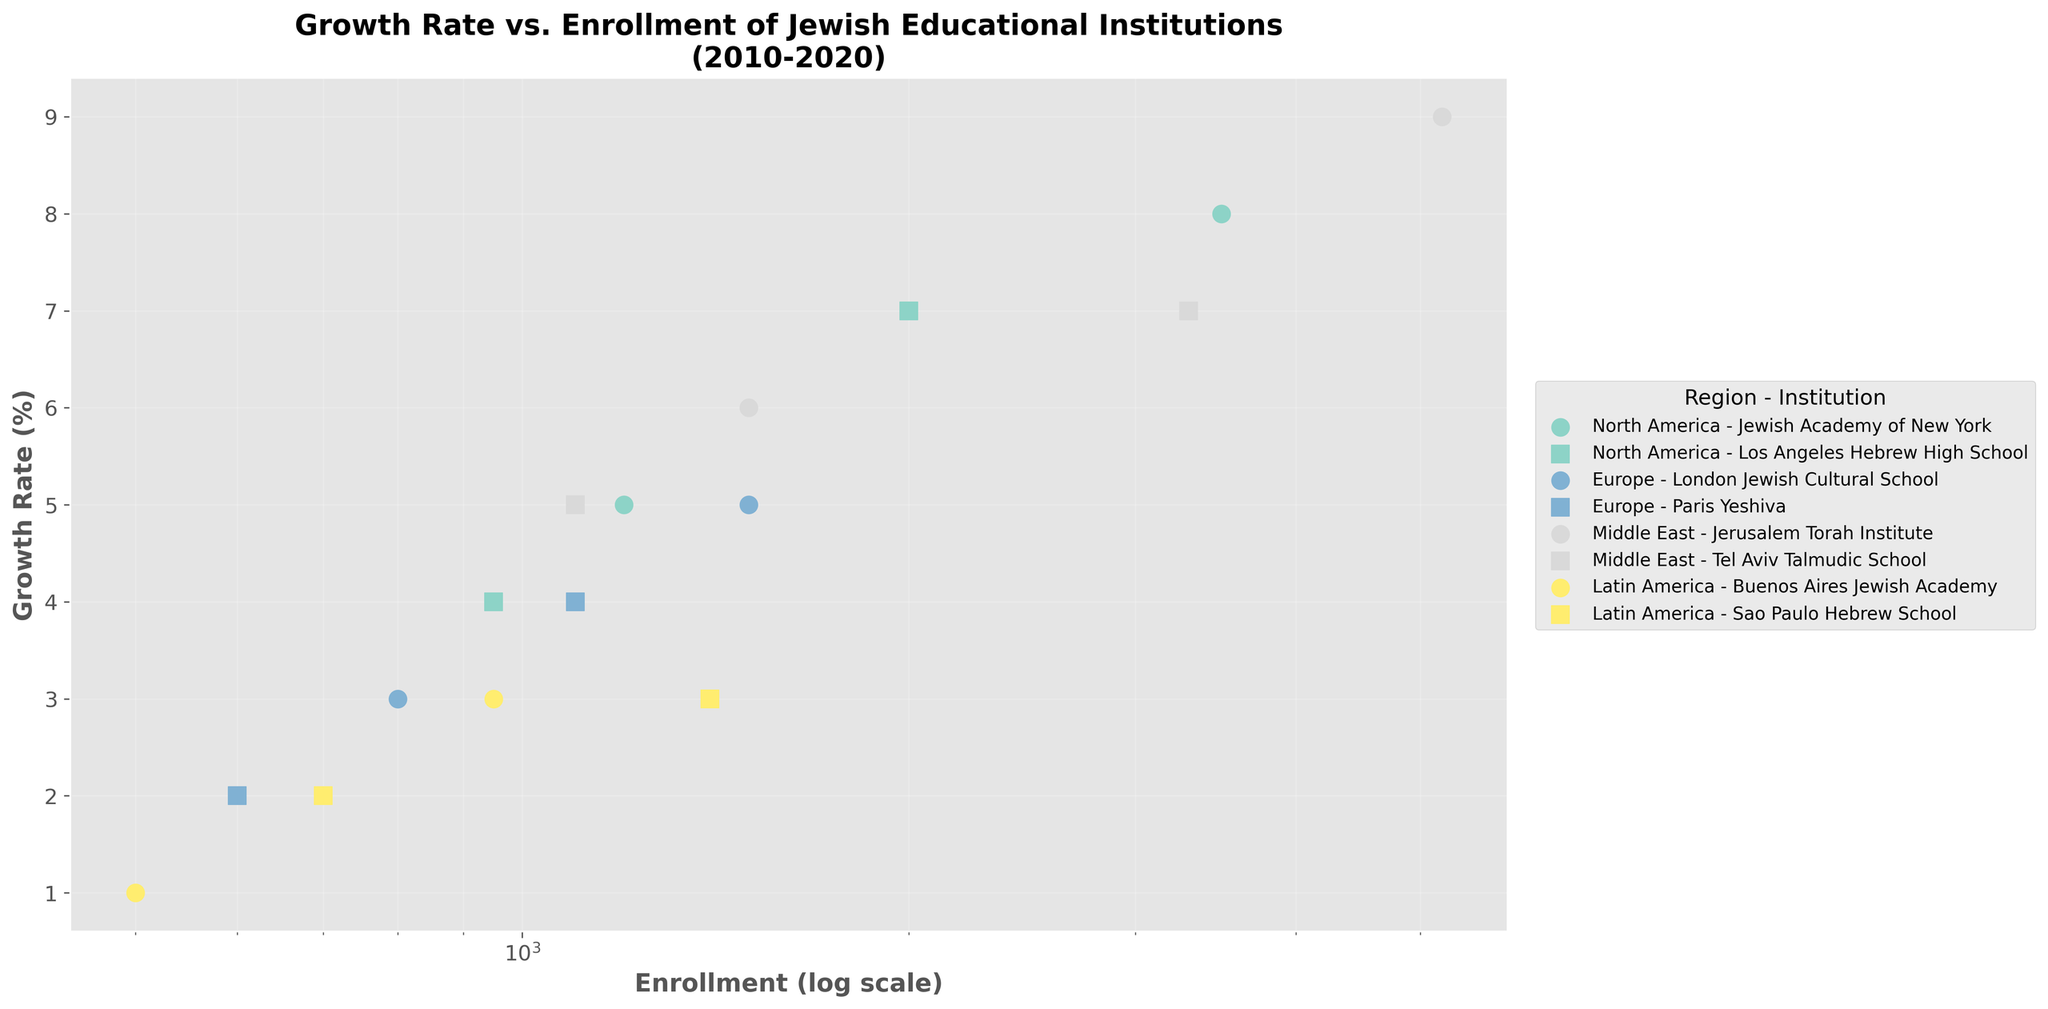What is the title of the plot? The title of the plot is displayed at the top and reads 'Growth Rate vs. Enrollment of Jewish Educational Institutions (2010-2020)'.
Answer: Growth Rate vs. Enrollment of Jewish Educational Institutions (2010-2020) What kind of scale is used for the x-axis? The scale of the x-axis is indicated in parentheses next to the label 'Enrollment' and is 'log scale'.
Answer: Log scale How many institutions are represented from North America? By looking at the legend, we can see two institutions from North America: Jewish Academy of New York and Los Angeles Hebrew High School.
Answer: 2 Which institution has the highest enrollment in 2020? Based on the data points' position along the x-axis (log scale), the Jerusalem Torah Institute from the Middle East has the highest enrollment at 5200.
Answer: Jerusalem Torah Institute What is the growth rate of Paris Yeshiva in 2020? Locate the Paris Yeshiva in the figure and refer to its position along the y-axis, which indicates the growth rate of 4%.
Answer: 4% Compare the growth rates of the Jewish Academy of New York and the Tel Aviv Talmudic School in 2020. Which one has a higher growth rate? Refer to the y-axis positions of both institutions in 2020. The Jewish Academy of New York has a growth rate of 8%, and the Tel Aviv Talmudic School has a rate of 7%. Hence, the Jewish Academy of New York has a higher growth rate.
Answer: Jewish Academy of New York Which region shows the greatest increase in enrollment from 2010 to 2020? Calculate the total increase in enrollment for each region and compare. The Middle East shows the greatest increase, driven by the Jerusalem Torah Institute and Tel Aviv Talmudic School.
Answer: Middle East How does the growth rate of European institutions in 2020 compare to those in Latin America? The growth rates of European institutions (5% for London Jewish Cultural School and 4% for Paris Yeshiva) are higher compared to those in Latin America (3% for both Buenos Aires Jewish Academy and Sao Paulo Hebrew School).
Answer: Higher in Europe What relationship do you observe between enrollment and growth rate, considering the log scale for enrollment? Generally, institutions with lower initial enrollments in 2010 tend to show higher growth rates by 2020, indicating that smaller institutions grow faster.
Answer: Smaller institutions grow faster 